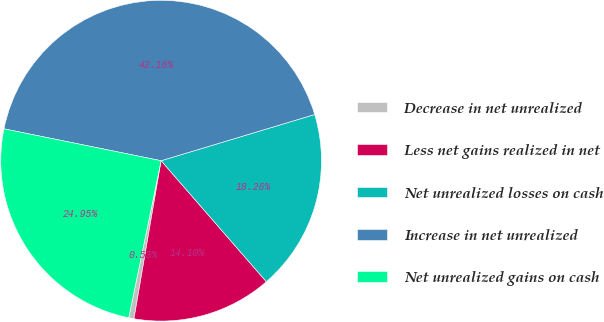Convert chart. <chart><loc_0><loc_0><loc_500><loc_500><pie_chart><fcel>Decrease in net unrealized<fcel>Less net gains realized in net<fcel>Net unrealized losses on cash<fcel>Increase in net unrealized<fcel>Net unrealized gains on cash<nl><fcel>0.53%<fcel>14.1%<fcel>18.26%<fcel>42.16%<fcel>24.95%<nl></chart> 